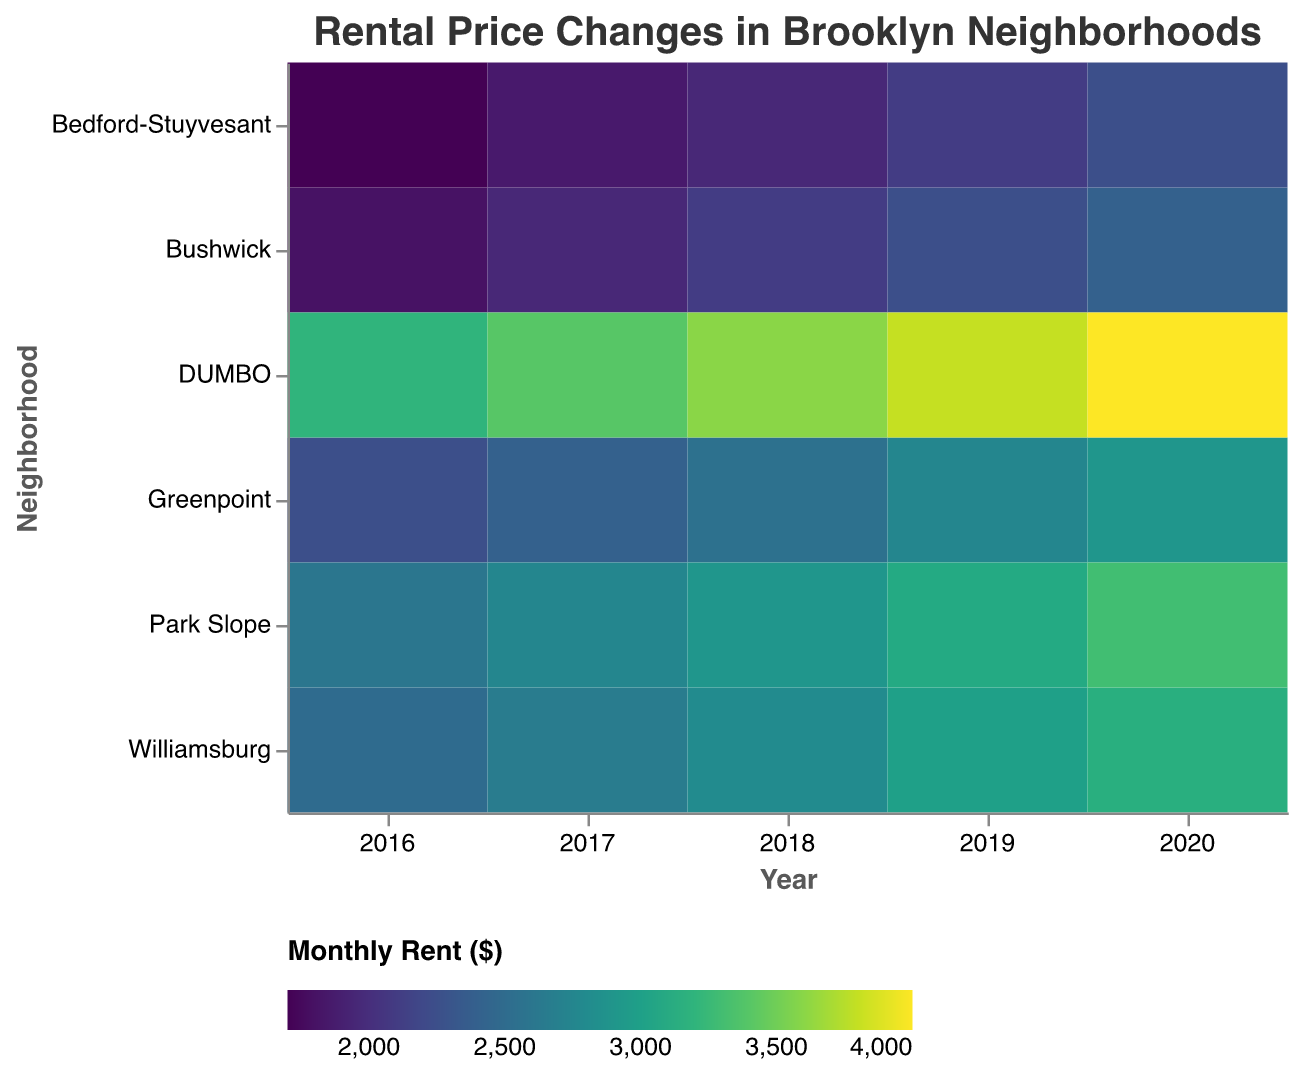What is the title of the heatmap? The title provides a concise description of the content of the figure. Here, "Rental Price Changes in Brooklyn Neighborhoods" is clearly shown at the top.
Answer: Rental Price Changes in Brooklyn Neighborhoods Which neighborhood had the highest rent in 2020? To answer this, find the color indicating the highest rent value in the column for the year 2020 and identify the corresponding neighborhood. DUMBO has the darkest shade representing the highest rent of $4000.
Answer: DUMBO What trend do you observe in Williamsburg's rental prices from 2016 to 2020? Observe the colors in the row for Williamsburg from the year 2016 to 2020. The color gradually darkens, indicating a steady increase in rental prices from $2500 in 2016 to $3150 in 2020.
Answer: Increasing trend Which neighborhood experienced the largest numerical increase in rent from 2016 to 2020? Calculate the difference in rent between 2020 and 2016 for each neighborhood and identify the largest increase. DUMBO starts at $3200 in 2016 and rises to $4000 in 2020, an increase of $800.
Answer: DUMBO How does Park Slope’s rent in 2017 compare to Bushwick’s rent in 2019? Locate Park Slope's rent value for 2017 and Bushwick's rent value for 2019. Park Slope's rent in 2017 is $2750, and Bushwick's rent in 2019 is $2250. Park Slope is higher by $500.
Answer: Park Slope's rent is higher by $500 What is the average rent in Greenpoint over the years 2016 to 2020? Sum Greenpoint's rents for each year and divide by the number of years. The total is $2250 + $2400 + $2550 + $2750 + $2900 = $12850. Divide by 5, the average is $2570.
Answer: $2570 Between Bedford-Stuyvesant and Bushwick, which neighborhood had a higher rent in 2018? Compare the rent values for Bedford-Stuyvesant and Bushwick in 2018. Bedford-Stuyvesant's rent is $1950 while Bushwick's is $2100. Bushwick has the higher rent.
Answer: Bushwick Which year did Park Slope see the highest rent increase compared to the previous year? Compare the differences in rent from one year to the next for Park Slope. The largest increase occurred from 2018 ($2900) to 2019 ($3100), which is an increase of $200.
Answer: 2019 